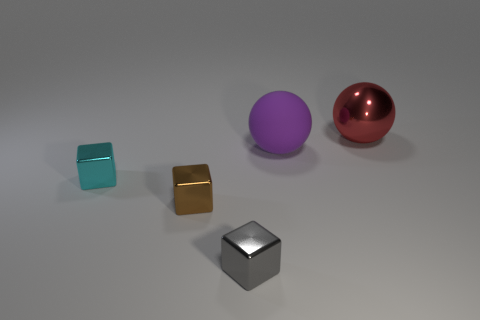Add 3 red metallic objects. How many objects exist? 8 Subtract all tiny brown metal blocks. How many blocks are left? 2 Subtract 2 spheres. How many spheres are left? 0 Subtract all red spheres. How many spheres are left? 1 Subtract all spheres. How many objects are left? 3 Add 5 red metallic spheres. How many red metallic spheres are left? 6 Add 4 big purple cubes. How many big purple cubes exist? 4 Subtract 1 brown blocks. How many objects are left? 4 Subtract all gray balls. Subtract all purple blocks. How many balls are left? 2 Subtract all cyan blocks. How many yellow spheres are left? 0 